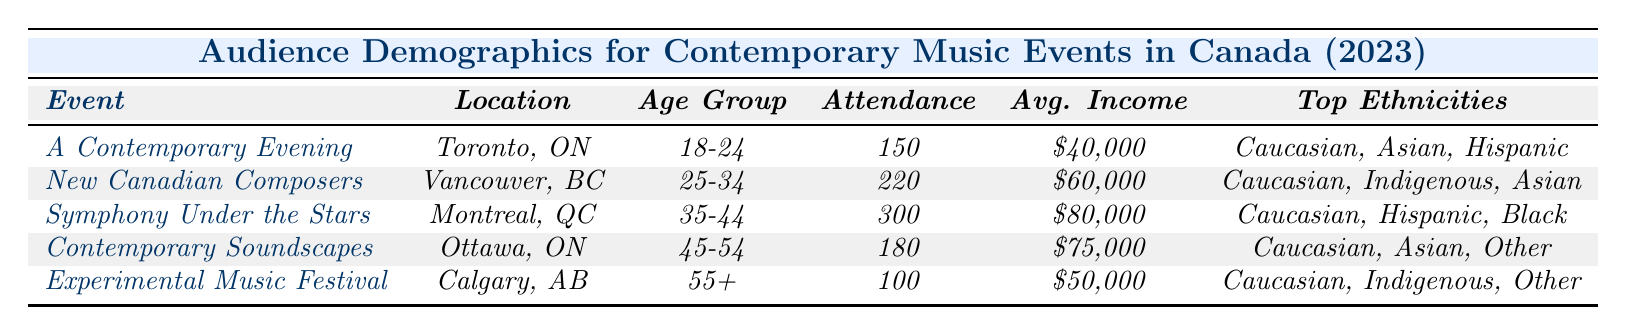What is the average income of attendees at the "Symphony Under the Stars"? The average income for attendees of "Symphony Under the Stars" is provided in the table. According to the table, it is listed as $80,000.
Answer: $80,000 How many people attended the "New Canadian Composers" event? The attendance count for "New Canadian Composers" is directly given in the table as 220.
Answer: 220 What age group had the highest attendance at contemporary music events? By reviewing the attendance counts in the table, "Symphony Under the Stars" had the highest attendance of 300 in the 35-44 age group.
Answer: 35-44 True or False: The average income of the audience for the "Experimental Music Festival" is higher than that of the "A Contemporary Evening." The average income for "Experimental Music Festival" is $50,000, and for "A Contemporary Evening," it is $40,000. $50,000 is greater than $40,000, so the statement is true.
Answer: True What is the total attendance for all events listed? Adding all attendance counts from the table: 150 (A Contemporary Evening) + 220 (New Canadian Composers) + 300 (Symphony Under the Stars) + 180 (Contemporary Soundscapes) + 100 (Experimental Music Festival) gives a total of 950.
Answer: 950 Which ethnic background is common in all listed events? By reviewing the ethnic backgrounds in each event, "Caucasian" appears in the ethnic background for all five events, confirming it is common across all.
Answer: Caucasian Was the "Contemporary Soundscapes" event more attended than the "Experimental Music Festival"? Comparing the attendance counts, "Contemporary Soundscapes" had 180 attendees, while "Experimental Music Festival" had 100. Since 180 is greater than 100, the answer is yes.
Answer: Yes In which city was the event with the highest average income located? The highest average income is $80,000, associated with the "Symphony Under the Stars," which took place in Montreal, QC.
Answer: Montreal, QC What is the age group with the lowest attendance, and how many attended? Looking at the attendance counts, the "Experimental Music Festival" had the lowest attendance of 100 within the 55+ age group.
Answer: 55+, 100 How does the average income of the 45-54 age group compare to the 25-34 age group? The average income for the 45-54 age group (Contemporary Soundscapes) is $75,000, while for the 25-34 age group (New Canadian Composers), it is $60,000. $75,000 is greater than $60,000, so the 45-54 age group has a higher average income.
Answer: Higher Which event had an attendance of more than 200? The table shows the "New Canadian Composers" (220) and "Symphony Under the Stars" (300) events had attendance of more than 200.
Answer: New Canadian Composers, Symphony Under the Stars 